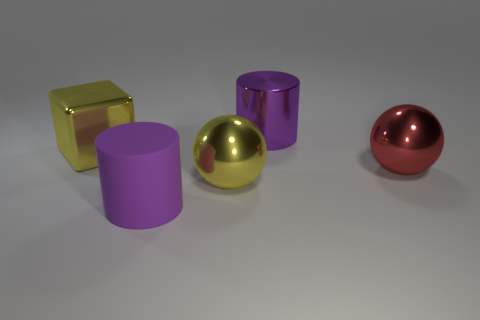Add 3 red matte cubes. How many objects exist? 8 Subtract all cylinders. How many objects are left? 3 Add 4 purple rubber objects. How many purple rubber objects exist? 5 Subtract 0 cyan cubes. How many objects are left? 5 Subtract all green metal blocks. Subtract all large matte cylinders. How many objects are left? 4 Add 2 large purple shiny things. How many large purple shiny things are left? 3 